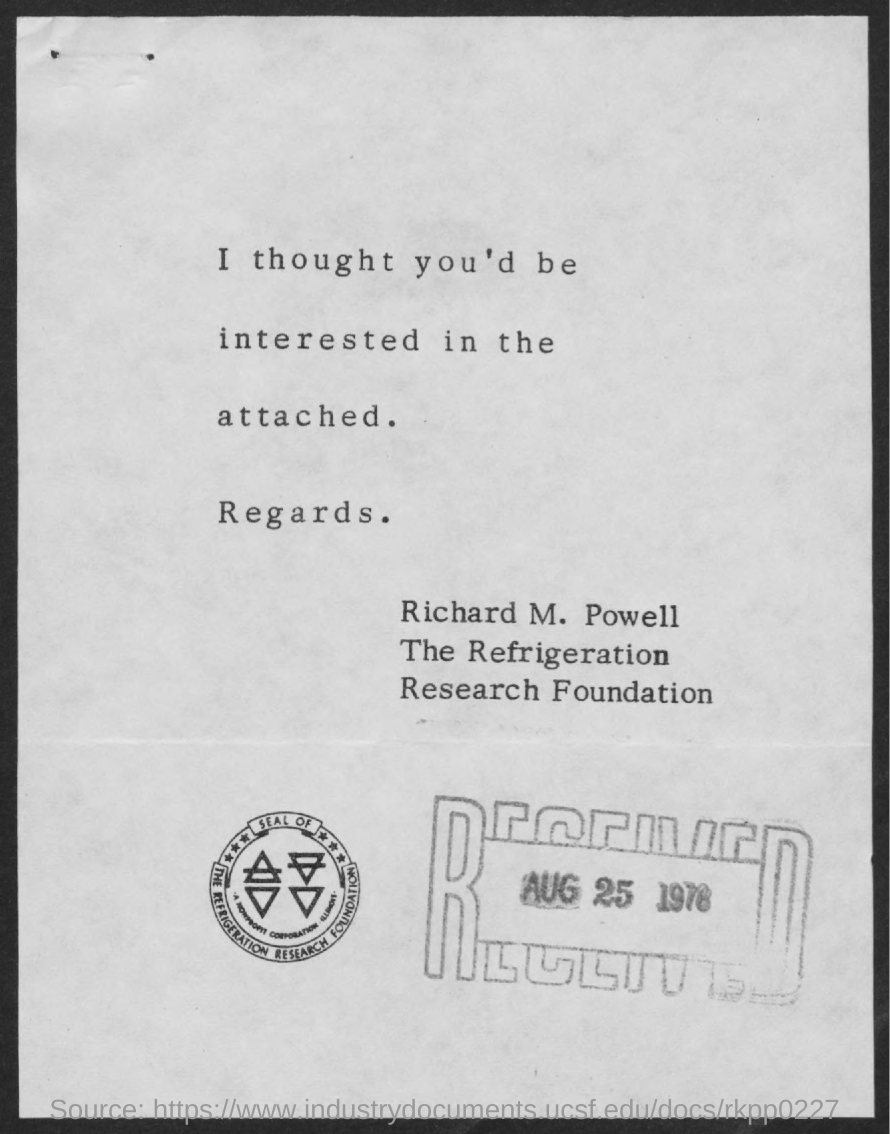What is the date on the stamp?
Your answer should be compact. Aug 25 1976. 